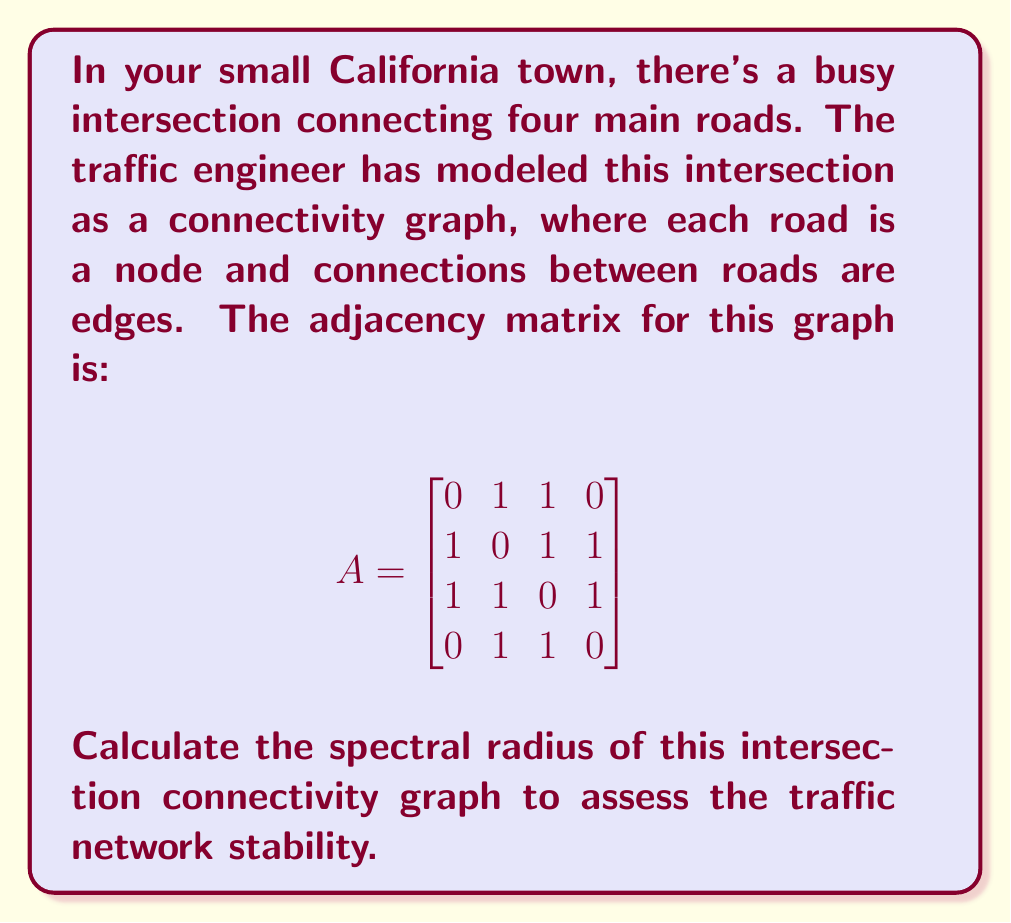Teach me how to tackle this problem. To find the spectral radius of the intersection connectivity graph, we need to follow these steps:

1) The spectral radius is the largest absolute eigenvalue of the adjacency matrix A.

2) To find the eigenvalues, we need to solve the characteristic equation:
   $$det(A - \lambda I) = 0$$
   where I is the 4x4 identity matrix and λ represents the eigenvalues.

3) Expanding this determinant:
   $$\begin{vmatrix}
   -\lambda & 1 & 1 & 0 \\
   1 & -\lambda & 1 & 1 \\
   1 & 1 & -\lambda & 1 \\
   0 & 1 & 1 & -\lambda
   \end{vmatrix} = 0$$

4) This expands to the characteristic polynomial:
   $$\lambda^4 - 5\lambda^2 - 4\lambda + 1 = 0$$

5) This is a 4th degree polynomial. While it can be solved analytically, it's complex. In practice, numerical methods would be used.

6) The roots of this polynomial are approximately:
   $$\lambda_1 \approx 2.4812, \lambda_2 \approx -1.7016, \lambda_3 \approx 0.5104, \lambda_4 \approx -0.2900$$

7) The spectral radius is the largest absolute value among these eigenvalues.

Therefore, the spectral radius of the intersection connectivity graph is approximately 2.4812.

This value being greater than 1 suggests that the traffic network may be prone to congestion or instability, which could be a concern for traffic safety in your small town.
Answer: $2.4812$ 